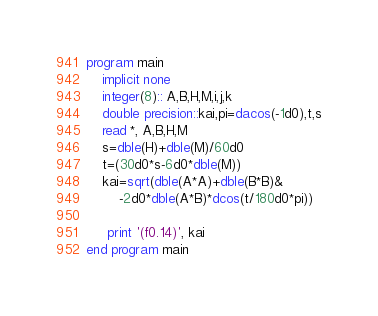Convert code to text. <code><loc_0><loc_0><loc_500><loc_500><_FORTRAN_>program main
	implicit none
	integer(8):: A,B,H,M,i,j,k
	double precision::kai,pi=dacos(-1d0),t,s
	read *, A,B,H,M	
	s=dble(H)+dble(M)/60d0
	t=(30d0*s-6d0*dble(M))
	kai=sqrt(dble(A*A)+dble(B*B)&
		-2d0*dble(A*B)*dcos(t/180d0*pi))
	
	 print '(f0.14)', kai
end program main</code> 